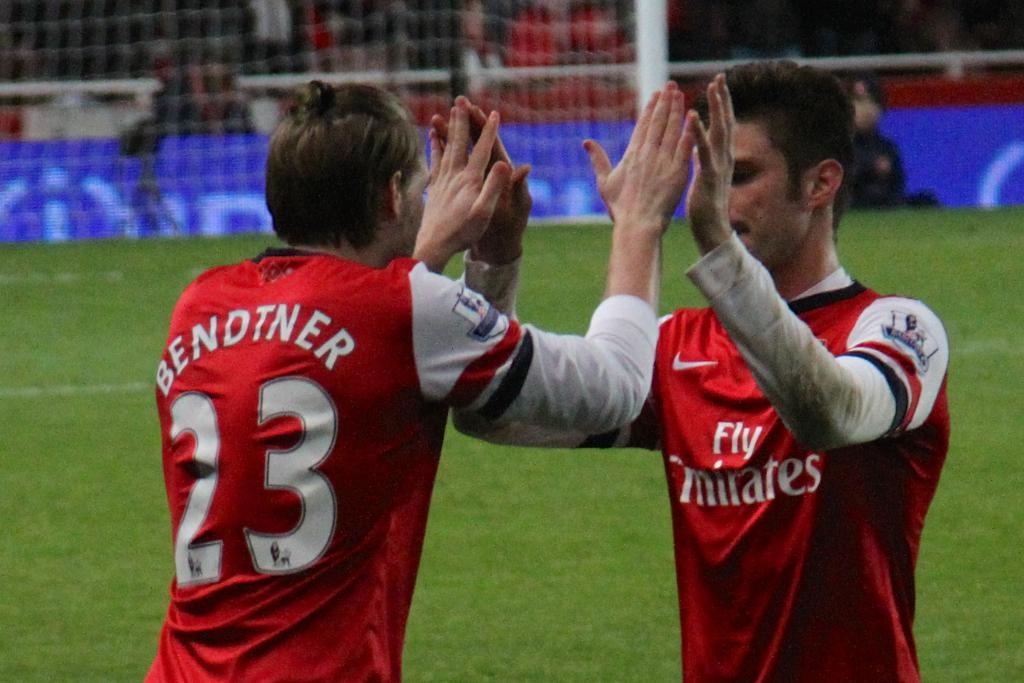<image>
Share a concise interpretation of the image provided. Two arsenal FC players, one called Bendtner high five on the pitch as one replaces the other. 